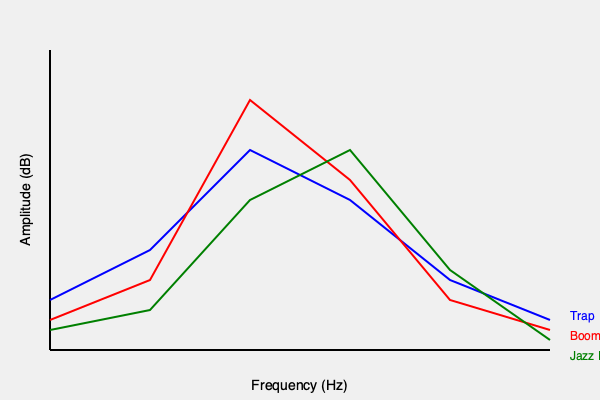Analyzing the frequency spectrum graph of three hip-hop sub-genres (Trap, Boom Bap, and Jazz Rap), which sub-genre typically exhibits the highest amplitude in the mid-frequency range (around 250-350 Hz)? To determine which hip-hop sub-genre has the highest amplitude in the mid-frequency range, we need to follow these steps:

1. Identify the mid-frequency range on the graph:
   The mid-frequency range is around 250-350 Hz, which corresponds to the middle section of the x-axis.

2. Compare the amplitude (y-axis values) of each sub-genre in this range:
   a) Trap (blue line): Shows a moderate amplitude in this range.
   b) Boom Bap (red line): Displays a higher amplitude compared to Trap.
   c) Jazz Rap (green line): Exhibits the highest amplitude in this range.

3. Analyze the characteristics of each sub-genre:
   a) Trap often emphasizes low frequencies and high frequencies (for bass and hi-hats).
   b) Boom Bap typically has a balanced frequency spectrum with emphasis on bass and snare.
   c) Jazz Rap incorporates more mid-range frequencies due to the use of jazz samples and live instruments.

4. Consider the production techniques:
   Jazz Rap often uses samples from jazz recordings or live instruments, which tend to occupy more of the mid-frequency range. This explains its higher amplitude in this area.

5. Conclude based on the graph and genre characteristics:
   The green line, representing Jazz Rap, clearly shows the highest peak in the 250-350 Hz range.

Therefore, among these three sub-genres, Jazz Rap typically exhibits the highest amplitude in the mid-frequency range.
Answer: Jazz Rap 